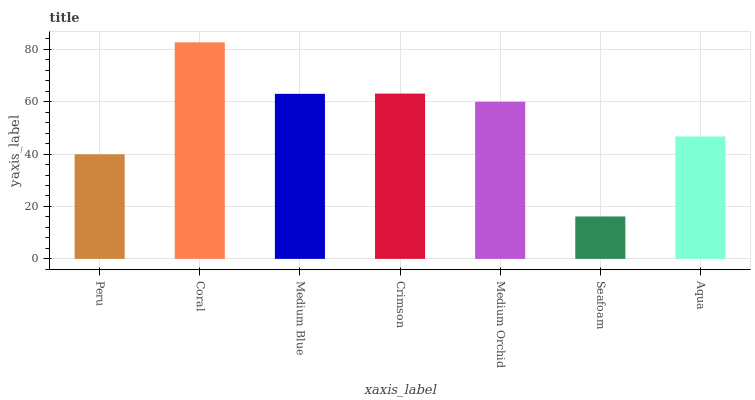Is Seafoam the minimum?
Answer yes or no. Yes. Is Coral the maximum?
Answer yes or no. Yes. Is Medium Blue the minimum?
Answer yes or no. No. Is Medium Blue the maximum?
Answer yes or no. No. Is Coral greater than Medium Blue?
Answer yes or no. Yes. Is Medium Blue less than Coral?
Answer yes or no. Yes. Is Medium Blue greater than Coral?
Answer yes or no. No. Is Coral less than Medium Blue?
Answer yes or no. No. Is Medium Orchid the high median?
Answer yes or no. Yes. Is Medium Orchid the low median?
Answer yes or no. Yes. Is Medium Blue the high median?
Answer yes or no. No. Is Crimson the low median?
Answer yes or no. No. 